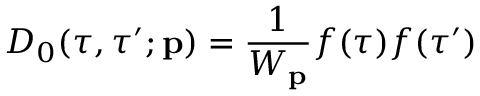<formula> <loc_0><loc_0><loc_500><loc_500>D _ { 0 } ( \tau , \tau ^ { \prime } ; { p } ) = \frac { 1 } { W _ { p } } f ( \tau ) f ( \tau ^ { \prime } )</formula> 